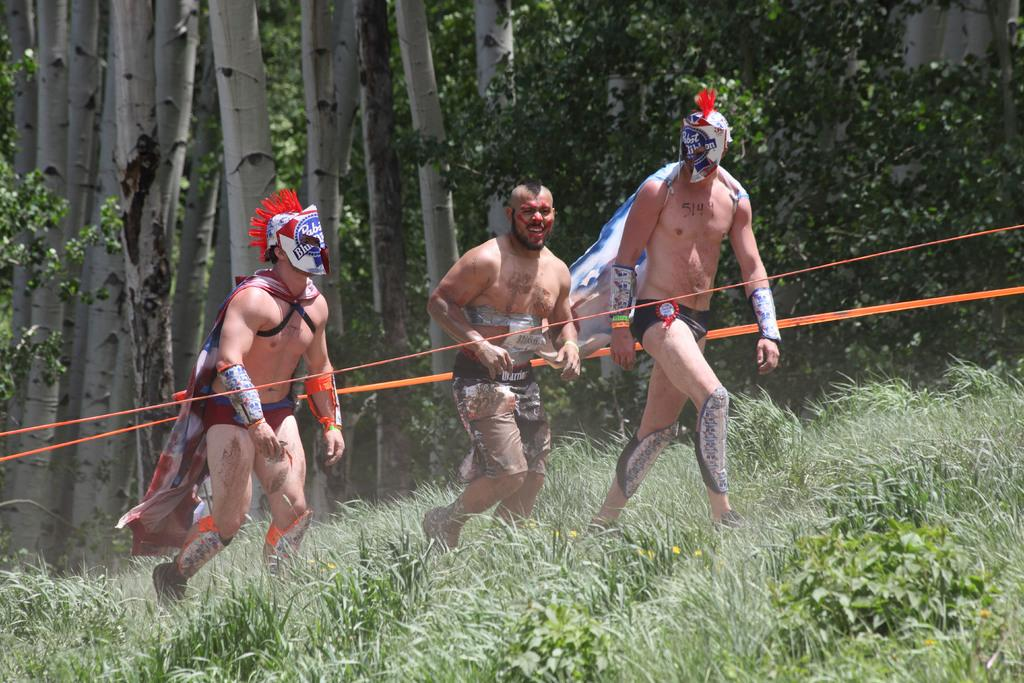How many men are in the foreground of the image? There are three men in the foreground of the image. What is the surface the men are standing on? The men are on the grass. What is the nature of the objects between the men? There are two orange ribbons between the men. What can be seen in the background of the image? There are trees and grass visible in the background of the image. What type of harmony is being played by the volcano in the image? There is no volcano present in the image, and therefore no music or harmony can be associated with it. What role does the cast play in the image? There is no cast mentioned or visible in the image. 